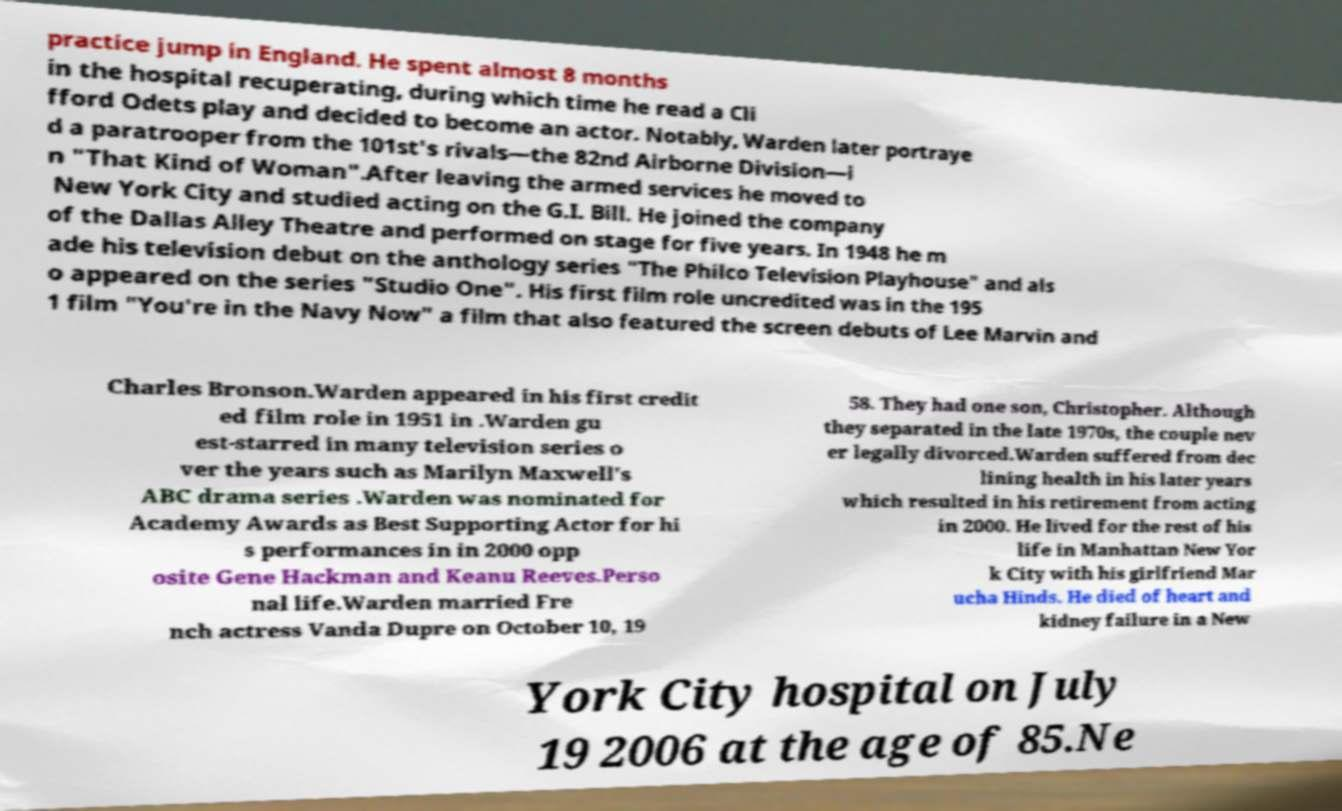Please identify and transcribe the text found in this image. practice jump in England. He spent almost 8 months in the hospital recuperating, during which time he read a Cli fford Odets play and decided to become an actor. Notably, Warden later portraye d a paratrooper from the 101st's rivals—the 82nd Airborne Division—i n "That Kind of Woman".After leaving the armed services he moved to New York City and studied acting on the G.I. Bill. He joined the company of the Dallas Alley Theatre and performed on stage for five years. In 1948 he m ade his television debut on the anthology series "The Philco Television Playhouse" and als o appeared on the series "Studio One". His first film role uncredited was in the 195 1 film "You're in the Navy Now" a film that also featured the screen debuts of Lee Marvin and Charles Bronson.Warden appeared in his first credit ed film role in 1951 in .Warden gu est-starred in many television series o ver the years such as Marilyn Maxwell's ABC drama series .Warden was nominated for Academy Awards as Best Supporting Actor for hi s performances in in 2000 opp osite Gene Hackman and Keanu Reeves.Perso nal life.Warden married Fre nch actress Vanda Dupre on October 10, 19 58. They had one son, Christopher. Although they separated in the late 1970s, the couple nev er legally divorced.Warden suffered from dec lining health in his later years which resulted in his retirement from acting in 2000. He lived for the rest of his life in Manhattan New Yor k City with his girlfriend Mar ucha Hinds. He died of heart and kidney failure in a New York City hospital on July 19 2006 at the age of 85.Ne 